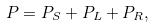Convert formula to latex. <formula><loc_0><loc_0><loc_500><loc_500>P = P _ { S } + P _ { L } + P _ { R } ,</formula> 